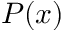Convert formula to latex. <formula><loc_0><loc_0><loc_500><loc_500>P ( x )</formula> 